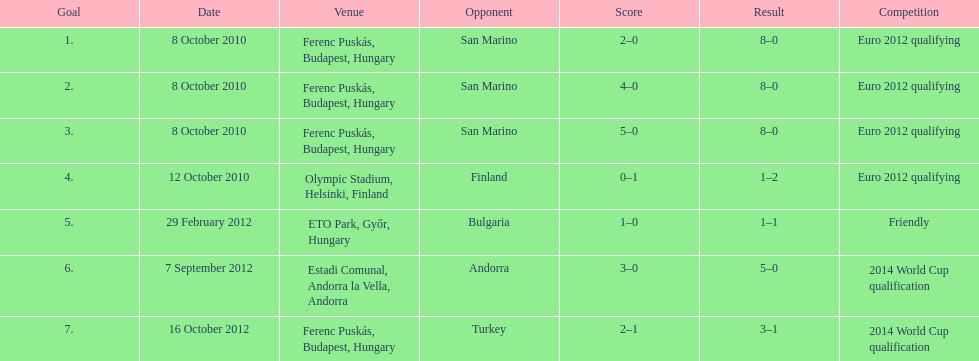When did ádám szalai make his first international goal? 8 October 2010. 